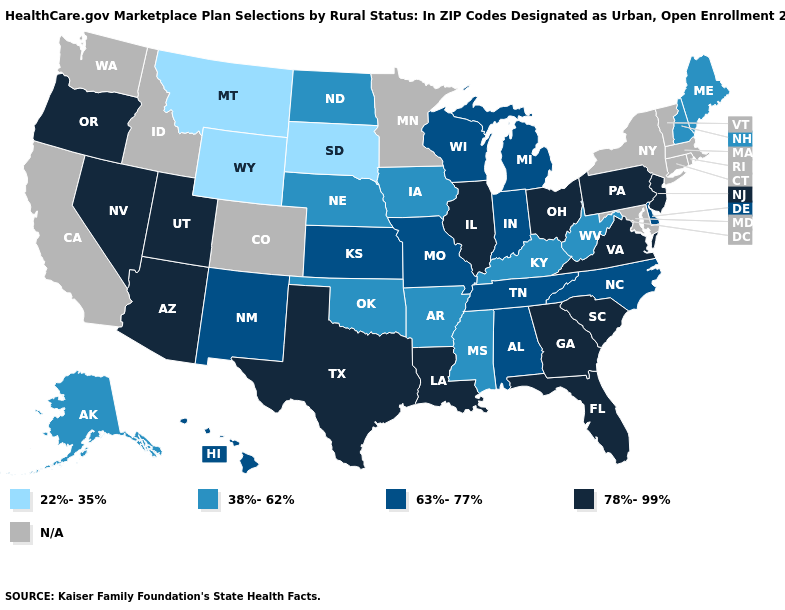Among the states that border Wyoming , which have the highest value?
Give a very brief answer. Utah. What is the value of Louisiana?
Concise answer only. 78%-99%. Among the states that border Missouri , which have the highest value?
Write a very short answer. Illinois. Which states have the lowest value in the USA?
Write a very short answer. Montana, South Dakota, Wyoming. Does Ohio have the highest value in the MidWest?
Keep it brief. Yes. Which states have the highest value in the USA?
Quick response, please. Arizona, Florida, Georgia, Illinois, Louisiana, Nevada, New Jersey, Ohio, Oregon, Pennsylvania, South Carolina, Texas, Utah, Virginia. Name the states that have a value in the range 38%-62%?
Be succinct. Alaska, Arkansas, Iowa, Kentucky, Maine, Mississippi, Nebraska, New Hampshire, North Dakota, Oklahoma, West Virginia. What is the value of South Carolina?
Keep it brief. 78%-99%. Does Virginia have the highest value in the South?
Short answer required. Yes. Does Kentucky have the lowest value in the USA?
Keep it brief. No. Name the states that have a value in the range 38%-62%?
Answer briefly. Alaska, Arkansas, Iowa, Kentucky, Maine, Mississippi, Nebraska, New Hampshire, North Dakota, Oklahoma, West Virginia. Name the states that have a value in the range 22%-35%?
Short answer required. Montana, South Dakota, Wyoming. What is the value of Wisconsin?
Answer briefly. 63%-77%. 